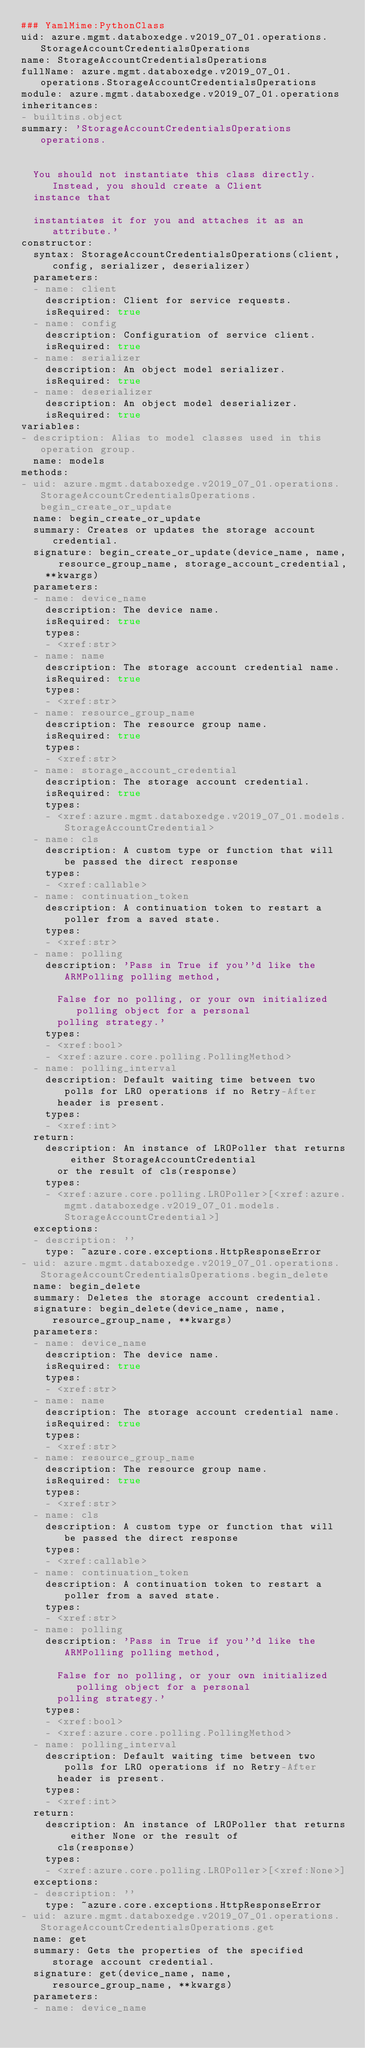<code> <loc_0><loc_0><loc_500><loc_500><_YAML_>### YamlMime:PythonClass
uid: azure.mgmt.databoxedge.v2019_07_01.operations.StorageAccountCredentialsOperations
name: StorageAccountCredentialsOperations
fullName: azure.mgmt.databoxedge.v2019_07_01.operations.StorageAccountCredentialsOperations
module: azure.mgmt.databoxedge.v2019_07_01.operations
inheritances:
- builtins.object
summary: 'StorageAccountCredentialsOperations operations.


  You should not instantiate this class directly. Instead, you should create a Client
  instance that

  instantiates it for you and attaches it as an attribute.'
constructor:
  syntax: StorageAccountCredentialsOperations(client, config, serializer, deserializer)
  parameters:
  - name: client
    description: Client for service requests.
    isRequired: true
  - name: config
    description: Configuration of service client.
    isRequired: true
  - name: serializer
    description: An object model serializer.
    isRequired: true
  - name: deserializer
    description: An object model deserializer.
    isRequired: true
variables:
- description: Alias to model classes used in this operation group.
  name: models
methods:
- uid: azure.mgmt.databoxedge.v2019_07_01.operations.StorageAccountCredentialsOperations.begin_create_or_update
  name: begin_create_or_update
  summary: Creates or updates the storage account credential.
  signature: begin_create_or_update(device_name, name, resource_group_name, storage_account_credential,
    **kwargs)
  parameters:
  - name: device_name
    description: The device name.
    isRequired: true
    types:
    - <xref:str>
  - name: name
    description: The storage account credential name.
    isRequired: true
    types:
    - <xref:str>
  - name: resource_group_name
    description: The resource group name.
    isRequired: true
    types:
    - <xref:str>
  - name: storage_account_credential
    description: The storage account credential.
    isRequired: true
    types:
    - <xref:azure.mgmt.databoxedge.v2019_07_01.models.StorageAccountCredential>
  - name: cls
    description: A custom type or function that will be passed the direct response
    types:
    - <xref:callable>
  - name: continuation_token
    description: A continuation token to restart a poller from a saved state.
    types:
    - <xref:str>
  - name: polling
    description: 'Pass in True if you''d like the ARMPolling polling method,

      False for no polling, or your own initialized polling object for a personal
      polling strategy.'
    types:
    - <xref:bool>
    - <xref:azure.core.polling.PollingMethod>
  - name: polling_interval
    description: Default waiting time between two polls for LRO operations if no Retry-After
      header is present.
    types:
    - <xref:int>
  return:
    description: An instance of LROPoller that returns either StorageAccountCredential
      or the result of cls(response)
    types:
    - <xref:azure.core.polling.LROPoller>[<xref:azure.mgmt.databoxedge.v2019_07_01.models.StorageAccountCredential>]
  exceptions:
  - description: ''
    type: ~azure.core.exceptions.HttpResponseError
- uid: azure.mgmt.databoxedge.v2019_07_01.operations.StorageAccountCredentialsOperations.begin_delete
  name: begin_delete
  summary: Deletes the storage account credential.
  signature: begin_delete(device_name, name, resource_group_name, **kwargs)
  parameters:
  - name: device_name
    description: The device name.
    isRequired: true
    types:
    - <xref:str>
  - name: name
    description: The storage account credential name.
    isRequired: true
    types:
    - <xref:str>
  - name: resource_group_name
    description: The resource group name.
    isRequired: true
    types:
    - <xref:str>
  - name: cls
    description: A custom type or function that will be passed the direct response
    types:
    - <xref:callable>
  - name: continuation_token
    description: A continuation token to restart a poller from a saved state.
    types:
    - <xref:str>
  - name: polling
    description: 'Pass in True if you''d like the ARMPolling polling method,

      False for no polling, or your own initialized polling object for a personal
      polling strategy.'
    types:
    - <xref:bool>
    - <xref:azure.core.polling.PollingMethod>
  - name: polling_interval
    description: Default waiting time between two polls for LRO operations if no Retry-After
      header is present.
    types:
    - <xref:int>
  return:
    description: An instance of LROPoller that returns either None or the result of
      cls(response)
    types:
    - <xref:azure.core.polling.LROPoller>[<xref:None>]
  exceptions:
  - description: ''
    type: ~azure.core.exceptions.HttpResponseError
- uid: azure.mgmt.databoxedge.v2019_07_01.operations.StorageAccountCredentialsOperations.get
  name: get
  summary: Gets the properties of the specified storage account credential.
  signature: get(device_name, name, resource_group_name, **kwargs)
  parameters:
  - name: device_name</code> 